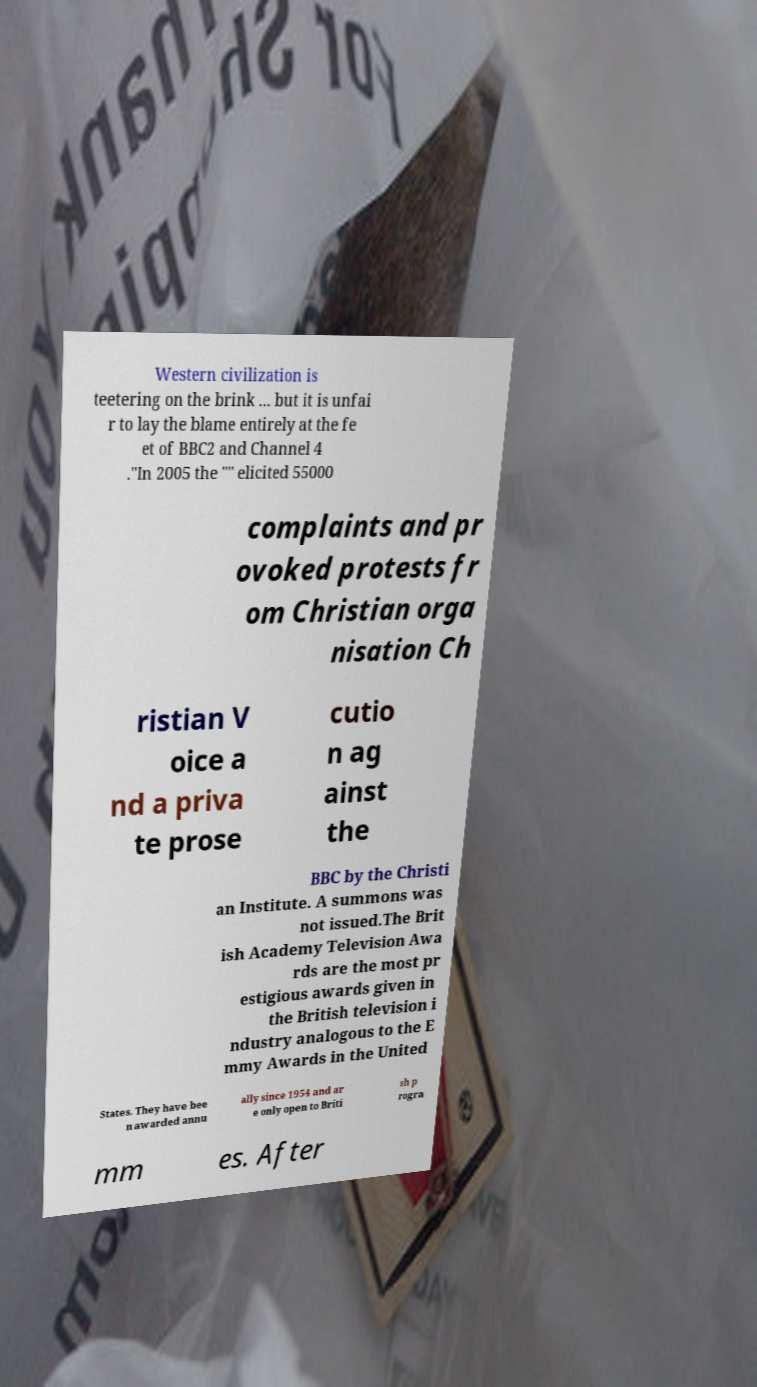Can you accurately transcribe the text from the provided image for me? Western civilization is teetering on the brink ... but it is unfai r to lay the blame entirely at the fe et of BBC2 and Channel 4 ."In 2005 the "" elicited 55000 complaints and pr ovoked protests fr om Christian orga nisation Ch ristian V oice a nd a priva te prose cutio n ag ainst the BBC by the Christi an Institute. A summons was not issued.The Brit ish Academy Television Awa rds are the most pr estigious awards given in the British television i ndustry analogous to the E mmy Awards in the United States. They have bee n awarded annu ally since 1954 and ar e only open to Briti sh p rogra mm es. After 